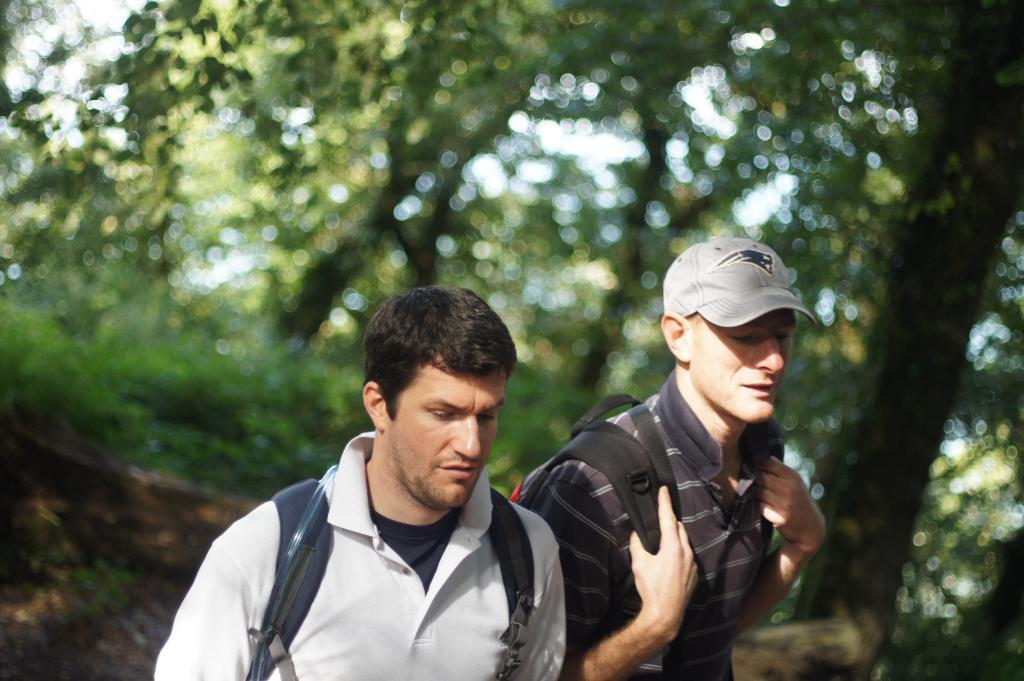Please provide a concise description of this image. In this image there are two persons with backpacks , and in the background there are trees. 